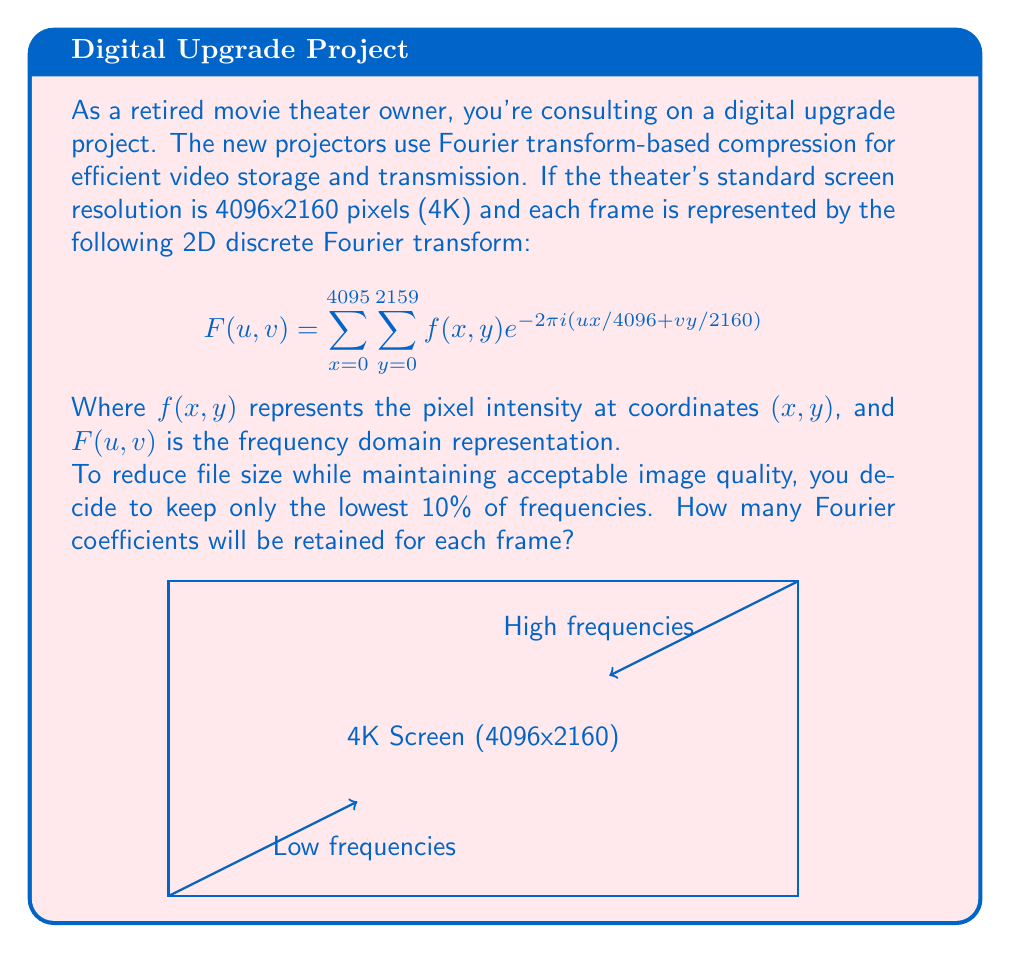Teach me how to tackle this problem. To solve this problem, we need to follow these steps:

1) First, let's understand what the question is asking. We need to find the number of Fourier coefficients that represent the lowest 10% of frequencies in a 4K image.

2) The total number of coefficients in the Fourier transform is equal to the number of pixels in the original image. For a 4K image (4096x2160), this is:

   $4096 \times 2160 = 8,847,360$ coefficients

3) The Fourier transform organizes these coefficients from lowest to highest frequency. The lowest frequencies contain the most important image information.

4) We're asked to keep only the lowest 10% of frequencies. To calculate this:

   $8,847,360 \times 10\% = 8,847,360 \times 0.10 = 884,736$ coefficients

5) Therefore, we will retain 884,736 Fourier coefficients for each frame.

This compression technique significantly reduces the data size while preserving the most crucial image information, which is typically contained in the lower frequencies. It's a balance between file size and image quality that's particularly useful for digital cinema projection systems.
Answer: 884,736 coefficients 